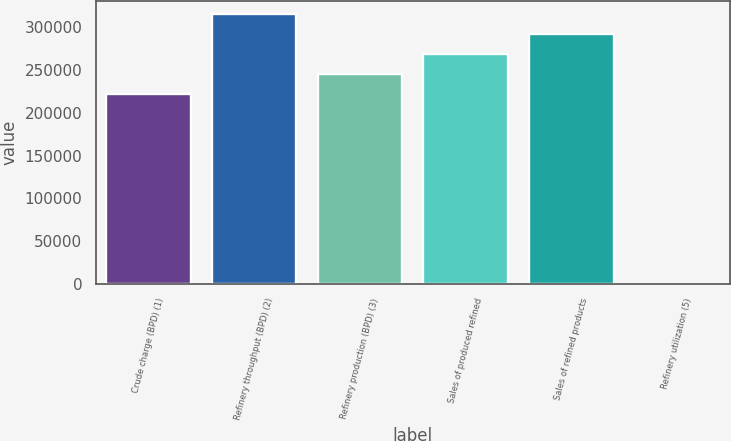Convert chart. <chart><loc_0><loc_0><loc_500><loc_500><bar_chart><fcel>Crude charge (BPD) (1)<fcel>Refinery throughput (BPD) (2)<fcel>Refinery production (BPD) (3)<fcel>Sales of produced refined<fcel>Sales of refined products<fcel>Refinery utilization (5)<nl><fcel>221440<fcel>315369<fcel>244922<fcel>268405<fcel>291887<fcel>86.5<nl></chart> 